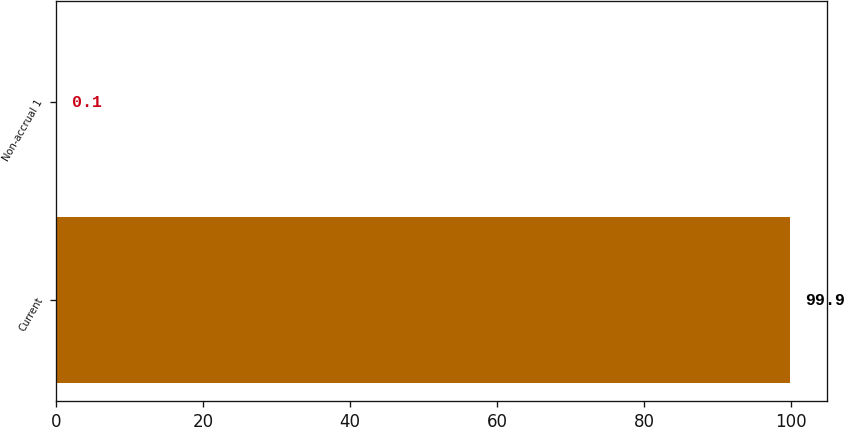Convert chart to OTSL. <chart><loc_0><loc_0><loc_500><loc_500><bar_chart><fcel>Current<fcel>Non-accrual 1<nl><fcel>99.9<fcel>0.1<nl></chart> 